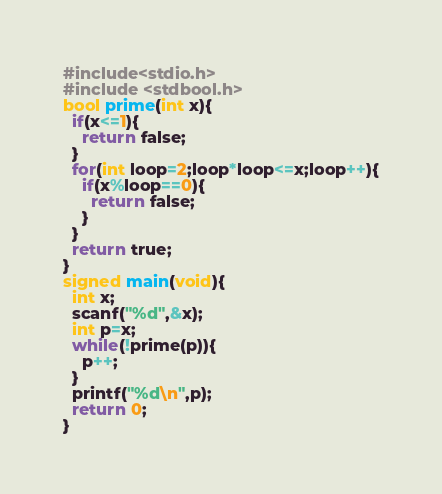<code> <loc_0><loc_0><loc_500><loc_500><_C_>#include<stdio.h>
#include <stdbool.h>
bool prime(int x){
  if(x<=1){
    return false;
  }
  for(int loop=2;loop*loop<=x;loop++){
    if(x%loop==0){
      return false;
    }
  }
  return true;
}
signed main(void){
  int x;
  scanf("%d",&x);
  int p=x;
  while(!prime(p)){
    p++;
  }
  printf("%d\n",p);
  return 0;
}
</code> 